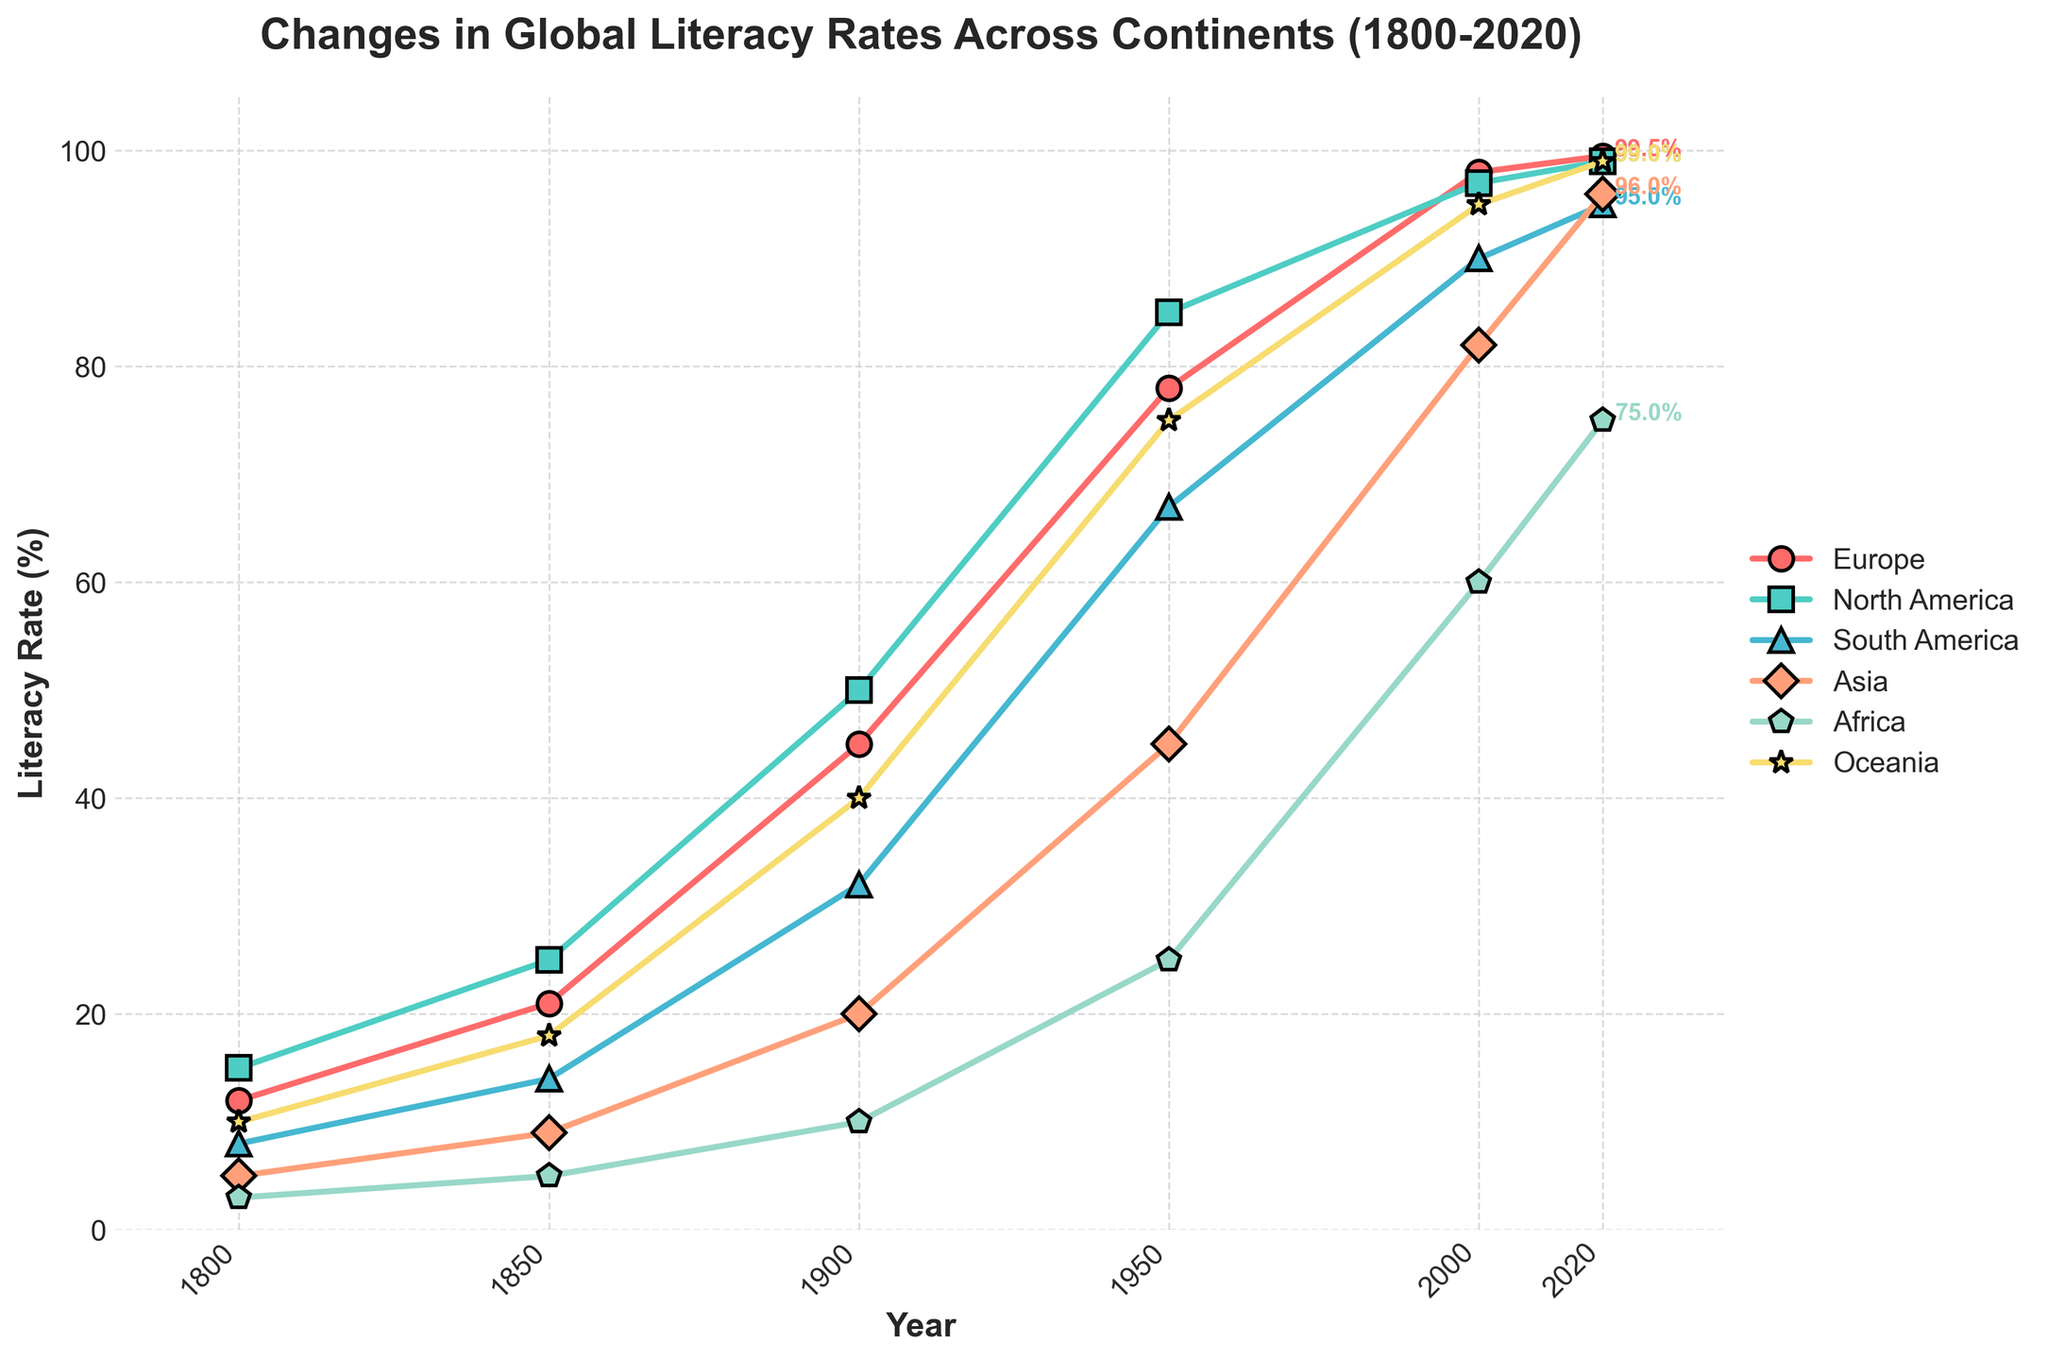Which continent had the highest literacy rate in 1800? The line chart shows the literacy rates of different continents over time. Looking at the year 1800, Europe had the highest literacy rate at 12%.
Answer: Europe Which continent displayed the largest increase in literacy rates from 1800 to 2020? By comparing the literacy rates of each continent from 1800 to 2020, we see that Africa increased from 3% to 75%, which is an increase of 72 percentage points. This is the largest increase among all continents.
Answer: Africa What is the approximate average literacy rate of Asia across all the years shown? To find the average literacy rate of Asia, we sum the literacy rates for the years 1800, 1850, 1900, 1950, 2000, and 2020, and then divide by the number of years. This gives (5 + 9 + 20 + 45 + 82 + 96) / 6 = 42.83% approximately.
Answer: 42.83% Which continents had a literacy rate below 50% in 1900? The literacy rates for the continents in 1900 are: Europe (45%), North America (50%), South America (32%), Asia (20%), Africa (10%), Oceania (40%). Only South America, Asia, Africa, and Oceania had rates below 50%.
Answer: South America, Asia, Africa, Oceania How does the literacy rate of Oceania in 1950 compare to that of North America in 1950? In 1950, Oceania's literacy rate was 75% and North America's was 85%. Comparing these two values, Oceania's rate is 10 percentage points less than North America's.
Answer: 10 percentage points less Which continent had the smallest increase in literacy rates between 1950 and 2000? To find the smallest increase, we calculate the difference for each continent between 1950 and 2000: Europe (98-78=20), North America (97-85=12), South America (90-67=23), Asia (82-45=37), Africa (60-25=35), Oceania (95-75=20). North America had the smallest increase of 12 percentage points.
Answer: North America What is the trend of literacy rate in Asia from 1900 to 2020? From the data, Asia's literacy rates increased over each period: 20% (1900), 45% (1950), 82% (2000), and 96% (2020). The trend shows a consistent and substantial increase.
Answer: Substantial increase By how many percentage points did Europe's literacy rate increase between 1800 and 1850? Europe’s literacy rates were 12% in 1800 and 21% in 1850. The increase is 21% - 12% = 9 percentage points.
Answer: 9 percentage points What distinguishes the literacy trends of Africa and Europe from 1950 to 2020? Examining the trends: Europe’s literacy increased moderately from 78% to 99.5%, a 21.5-point increase. Africa's literacy rate grew sharply from 25% to 75%, a 50-point increase. Africa shows a more dramatic rise.
Answer: Africa: sharp rise, Europe: moderate increase What was the literacy rate in South America in 1950 and how does it compare to that of Oceania in the same year? In 1950, South America's literacy rate was 67% and Oceania's was 75%. Oceania's rate was 8 percentage points higher than South America's.
Answer: 8 percentage points higher 